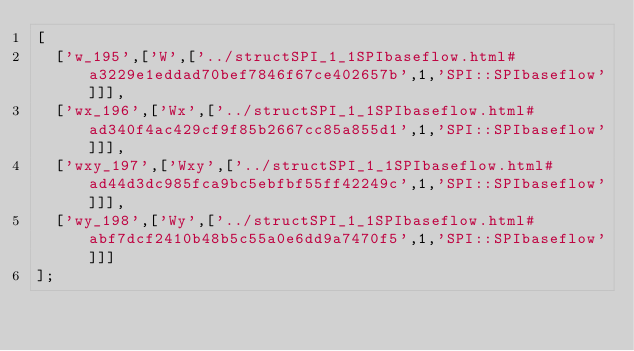<code> <loc_0><loc_0><loc_500><loc_500><_JavaScript_>[
  ['w_195',['W',['../structSPI_1_1SPIbaseflow.html#a3229e1eddad70bef7846f67ce402657b',1,'SPI::SPIbaseflow']]],
  ['wx_196',['Wx',['../structSPI_1_1SPIbaseflow.html#ad340f4ac429cf9f85b2667cc85a855d1',1,'SPI::SPIbaseflow']]],
  ['wxy_197',['Wxy',['../structSPI_1_1SPIbaseflow.html#ad44d3dc985fca9bc5ebfbf55ff42249c',1,'SPI::SPIbaseflow']]],
  ['wy_198',['Wy',['../structSPI_1_1SPIbaseflow.html#abf7dcf2410b48b5c55a0e6dd9a7470f5',1,'SPI::SPIbaseflow']]]
];
</code> 